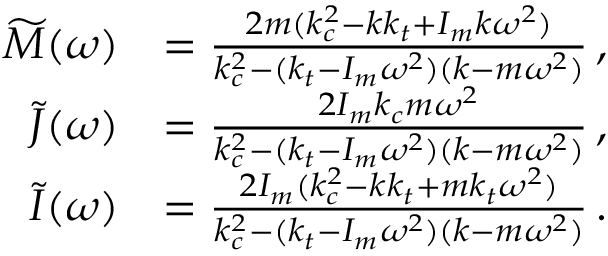<formula> <loc_0><loc_0><loc_500><loc_500>\begin{array} { r l } { \widetilde { M } ( \omega ) } & { = \frac { 2 m ( k _ { c } ^ { 2 } - k k _ { t } + I _ { m } k \omega ^ { 2 } ) } { k _ { c } ^ { 2 } - ( k _ { t } - I _ { m } \omega ^ { 2 } ) ( k - m \omega ^ { 2 } ) } \, , } \\ { \widetilde { J } ( \omega ) } & { = \frac { 2 I _ { m } k _ { c } m \omega ^ { 2 } } { k _ { c } ^ { 2 } - ( k _ { t } - I _ { m } \omega ^ { 2 } ) ( k - m \omega ^ { 2 } ) } \, , } \\ { \widetilde { I } ( \omega ) } & { = \frac { 2 I _ { m } ( k _ { c } ^ { 2 } - k k _ { t } + m k _ { t } \omega ^ { 2 } ) } { k _ { c } ^ { 2 } - ( k _ { t } - I _ { m } \omega ^ { 2 } ) ( k - m \omega ^ { 2 } ) } \, . } \end{array}</formula> 